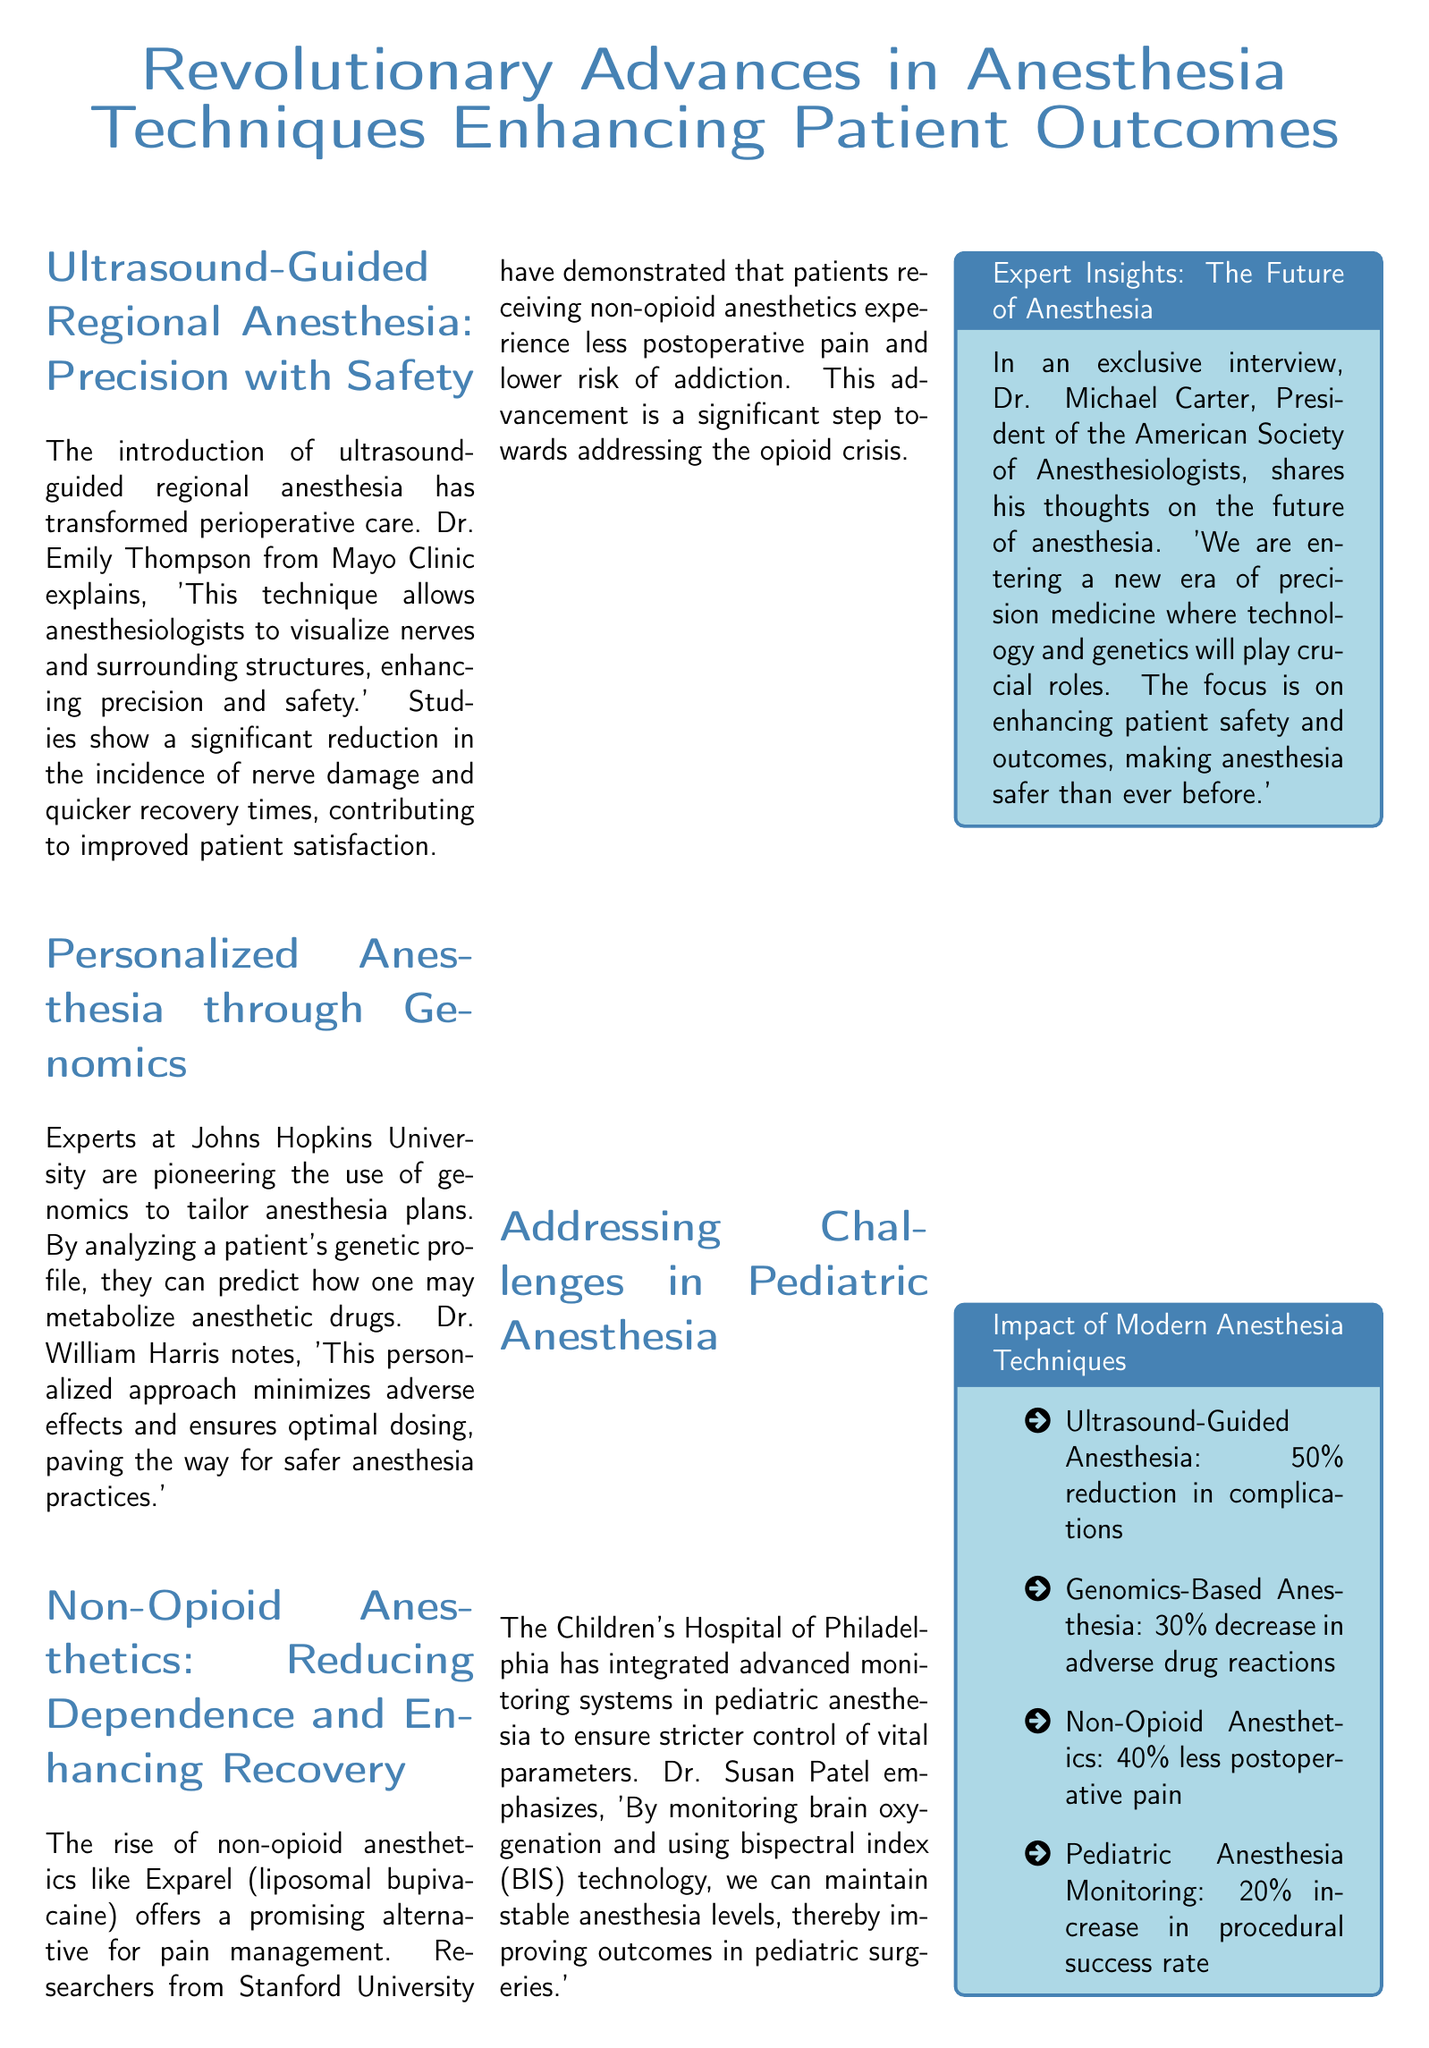What is the title of the article? The title is prominently displayed at the top of the document, summarizing the main focus.
Answer: Revolutionary Advances in Anesthesia Techniques Enhancing Patient Outcomes Who is the expert from Mayo Clinic mentioned in the article? The document attributes a quote regarding ultrasound-guided regional anesthesia to a specific doctor.
Answer: Dr. Emily Thompson What percentage reduction in complications does ultrasound-guided anesthesia provide? The document lists this specific percentage under the impact section.
Answer: 50% Which hospital is associated with advancements in pediatric anesthesia? The section addressing pediatric anesthesia specifically mentions this hospital.
Answer: The Children's Hospital of Philadelphia What is one notable benefit of using genomics in anesthesia? The document states a specific outcome achieved through genomics-based anesthesia practices.
Answer: 30% decrease in adverse drug reactions Which non-opioid anesthetic is mentioned as an alternative for pain management? The article refers to a specific non-opioid anesthetic used in pain management.
Answer: Exparel (liposomal bupivacaine) Who provided the quote about maintaining calmness during high-stress treatments? The quote of the day attributes the statement to a particular individual in anesthesiology.
Answer: Dr. Jane Smith What is the focus of Dr. Michael Carter's insights on the future of anesthesia? The document summarizes Dr. Carter's views outlined in the expert insights section.
Answer: Enhancing patient safety and outcomes What technology is used to monitor brain oxygenation in pediatric anesthesia? The relevant section describes the technology used for monitoring in pediatric anesthesia.
Answer: Bispectral index (BIS) technology 